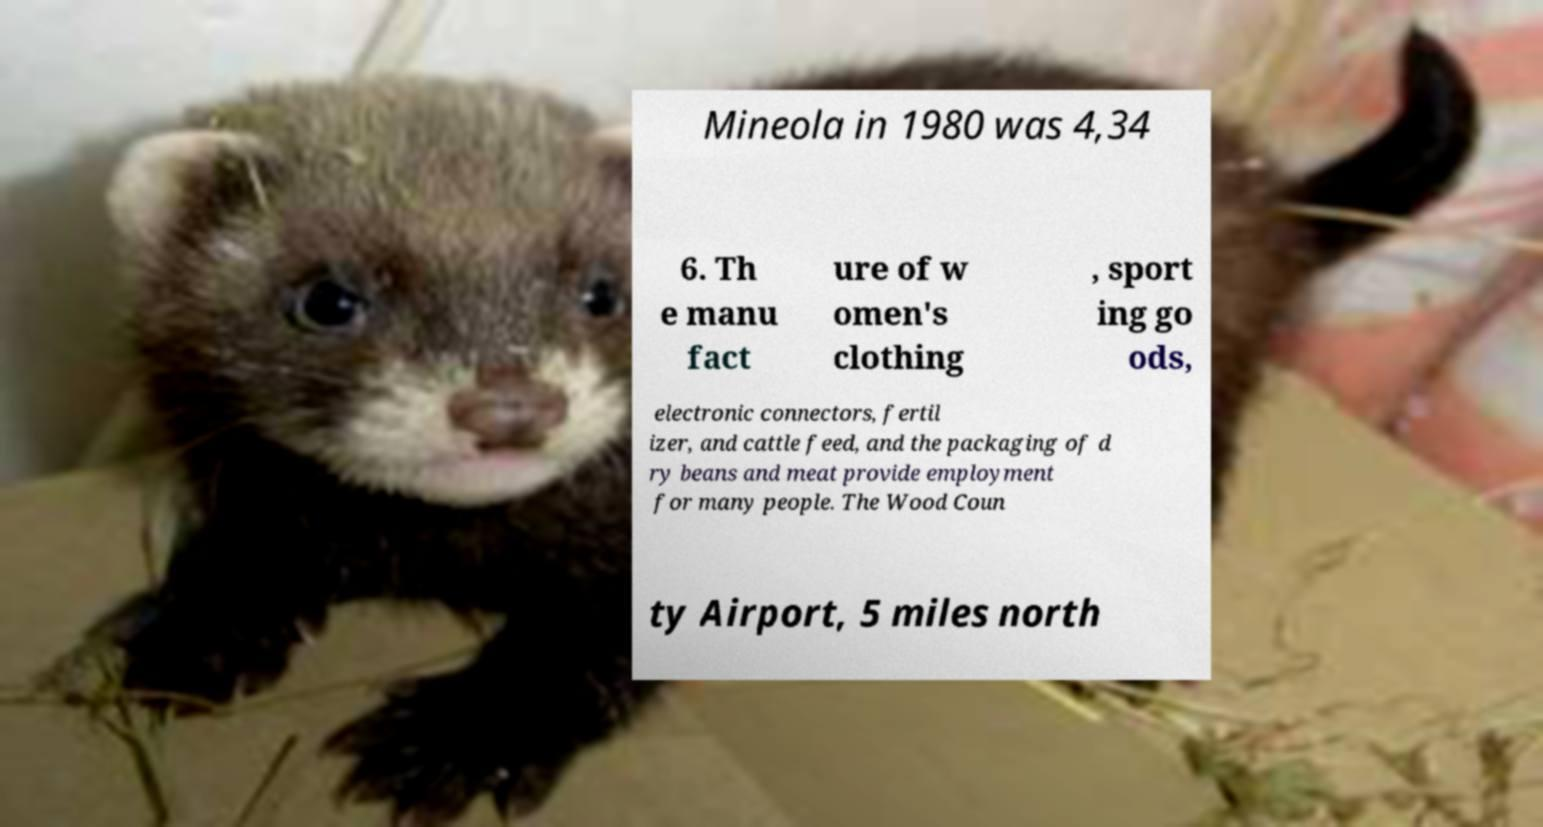Can you read and provide the text displayed in the image?This photo seems to have some interesting text. Can you extract and type it out for me? Mineola in 1980 was 4,34 6. Th e manu fact ure of w omen's clothing , sport ing go ods, electronic connectors, fertil izer, and cattle feed, and the packaging of d ry beans and meat provide employment for many people. The Wood Coun ty Airport, 5 miles north 